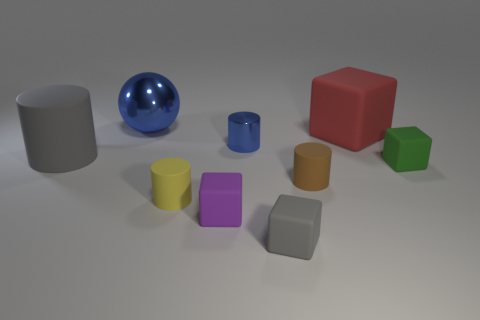What number of cylinders are either tiny shiny objects or large objects?
Offer a terse response. 2. There is a rubber thing that is on the left side of the tiny purple matte block and on the right side of the big blue ball; what is its shape?
Offer a very short reply. Cylinder. There is a small cylinder behind the big thing that is in front of the tiny object behind the big gray matte cylinder; what is its color?
Offer a terse response. Blue. Is the number of brown matte things that are in front of the yellow rubber cylinder less than the number of purple metal spheres?
Offer a terse response. No. Is the shape of the matte thing that is behind the blue metallic cylinder the same as the metallic object that is on the right side of the big blue sphere?
Keep it short and to the point. No. How many objects are big things that are to the left of the metal cylinder or large gray cylinders?
Offer a very short reply. 2. What is the material of the large thing that is the same color as the tiny shiny thing?
Offer a very short reply. Metal. Are there any large gray rubber things that are in front of the gray rubber thing that is right of the blue object behind the big matte cube?
Your answer should be very brief. No. Are there fewer tiny gray rubber objects that are behind the big metal object than red objects left of the gray cylinder?
Make the answer very short. No. There is a big cylinder that is made of the same material as the tiny purple block; what color is it?
Ensure brevity in your answer.  Gray. 